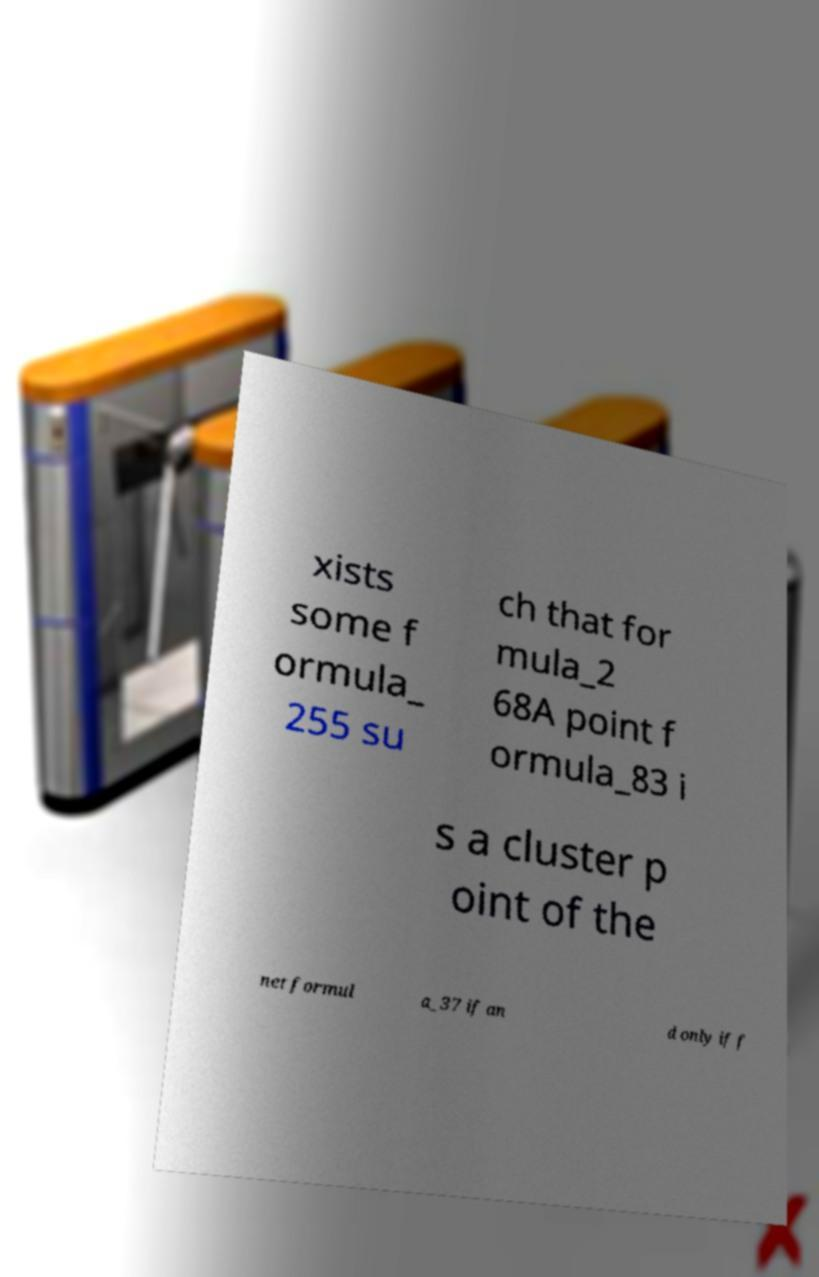What messages or text are displayed in this image? I need them in a readable, typed format. xists some f ormula_ 255 su ch that for mula_2 68A point f ormula_83 i s a cluster p oint of the net formul a_37 if an d only if f 